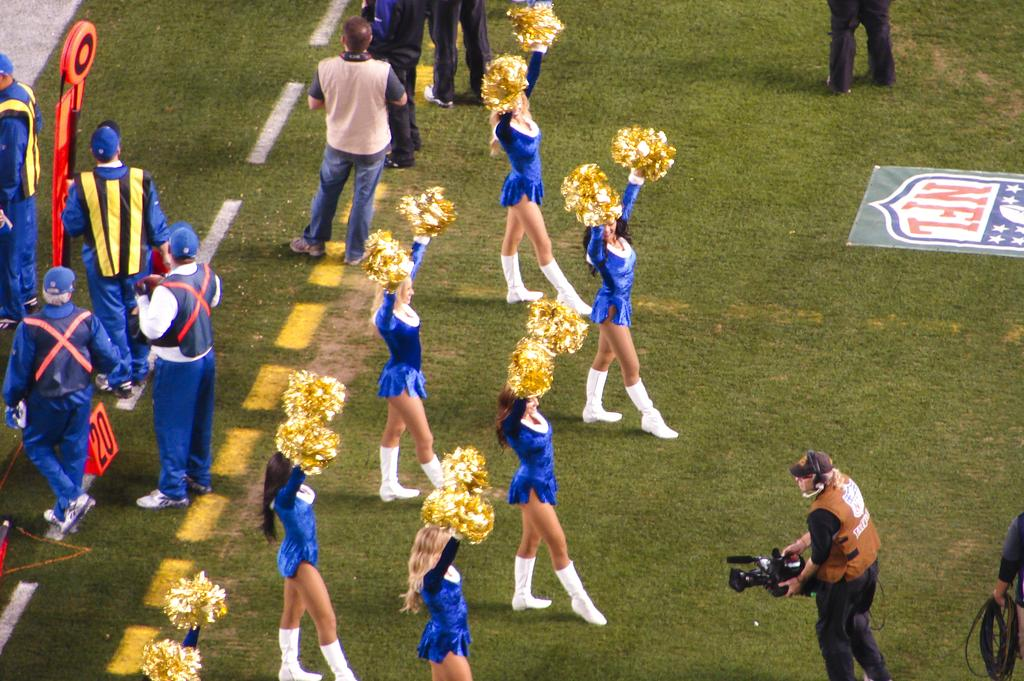<image>
Create a compact narrative representing the image presented. Cheerleaders are on a football field with the NFL logo on the ground. 